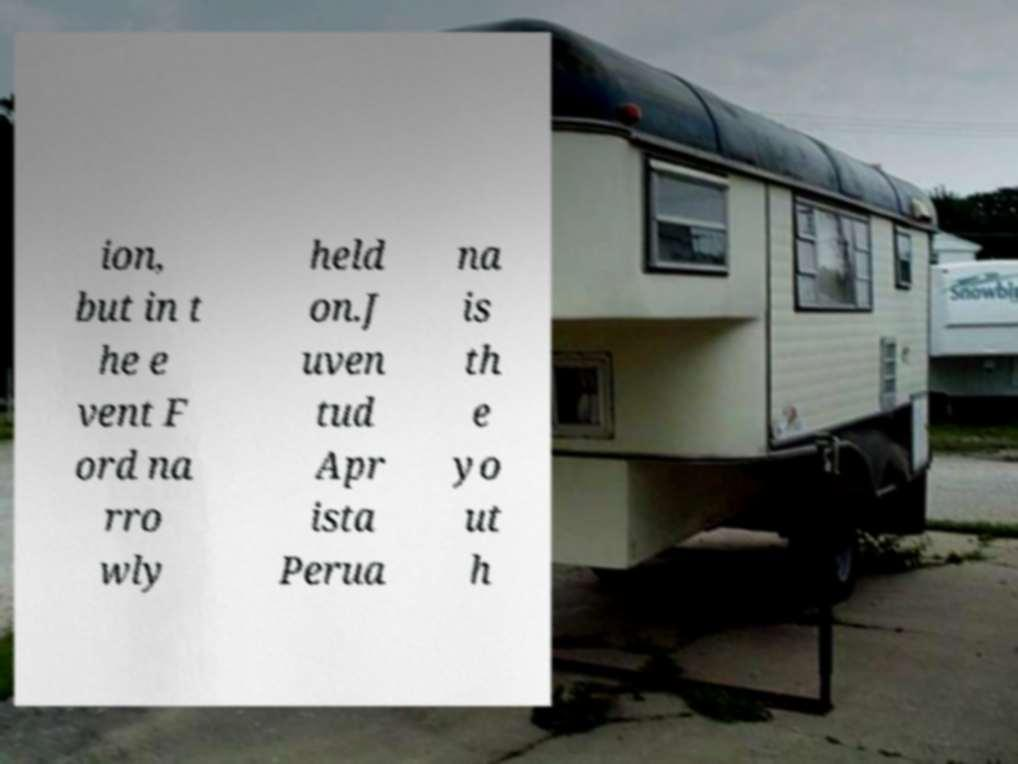Can you read and provide the text displayed in the image?This photo seems to have some interesting text. Can you extract and type it out for me? ion, but in t he e vent F ord na rro wly held on.J uven tud Apr ista Perua na is th e yo ut h 